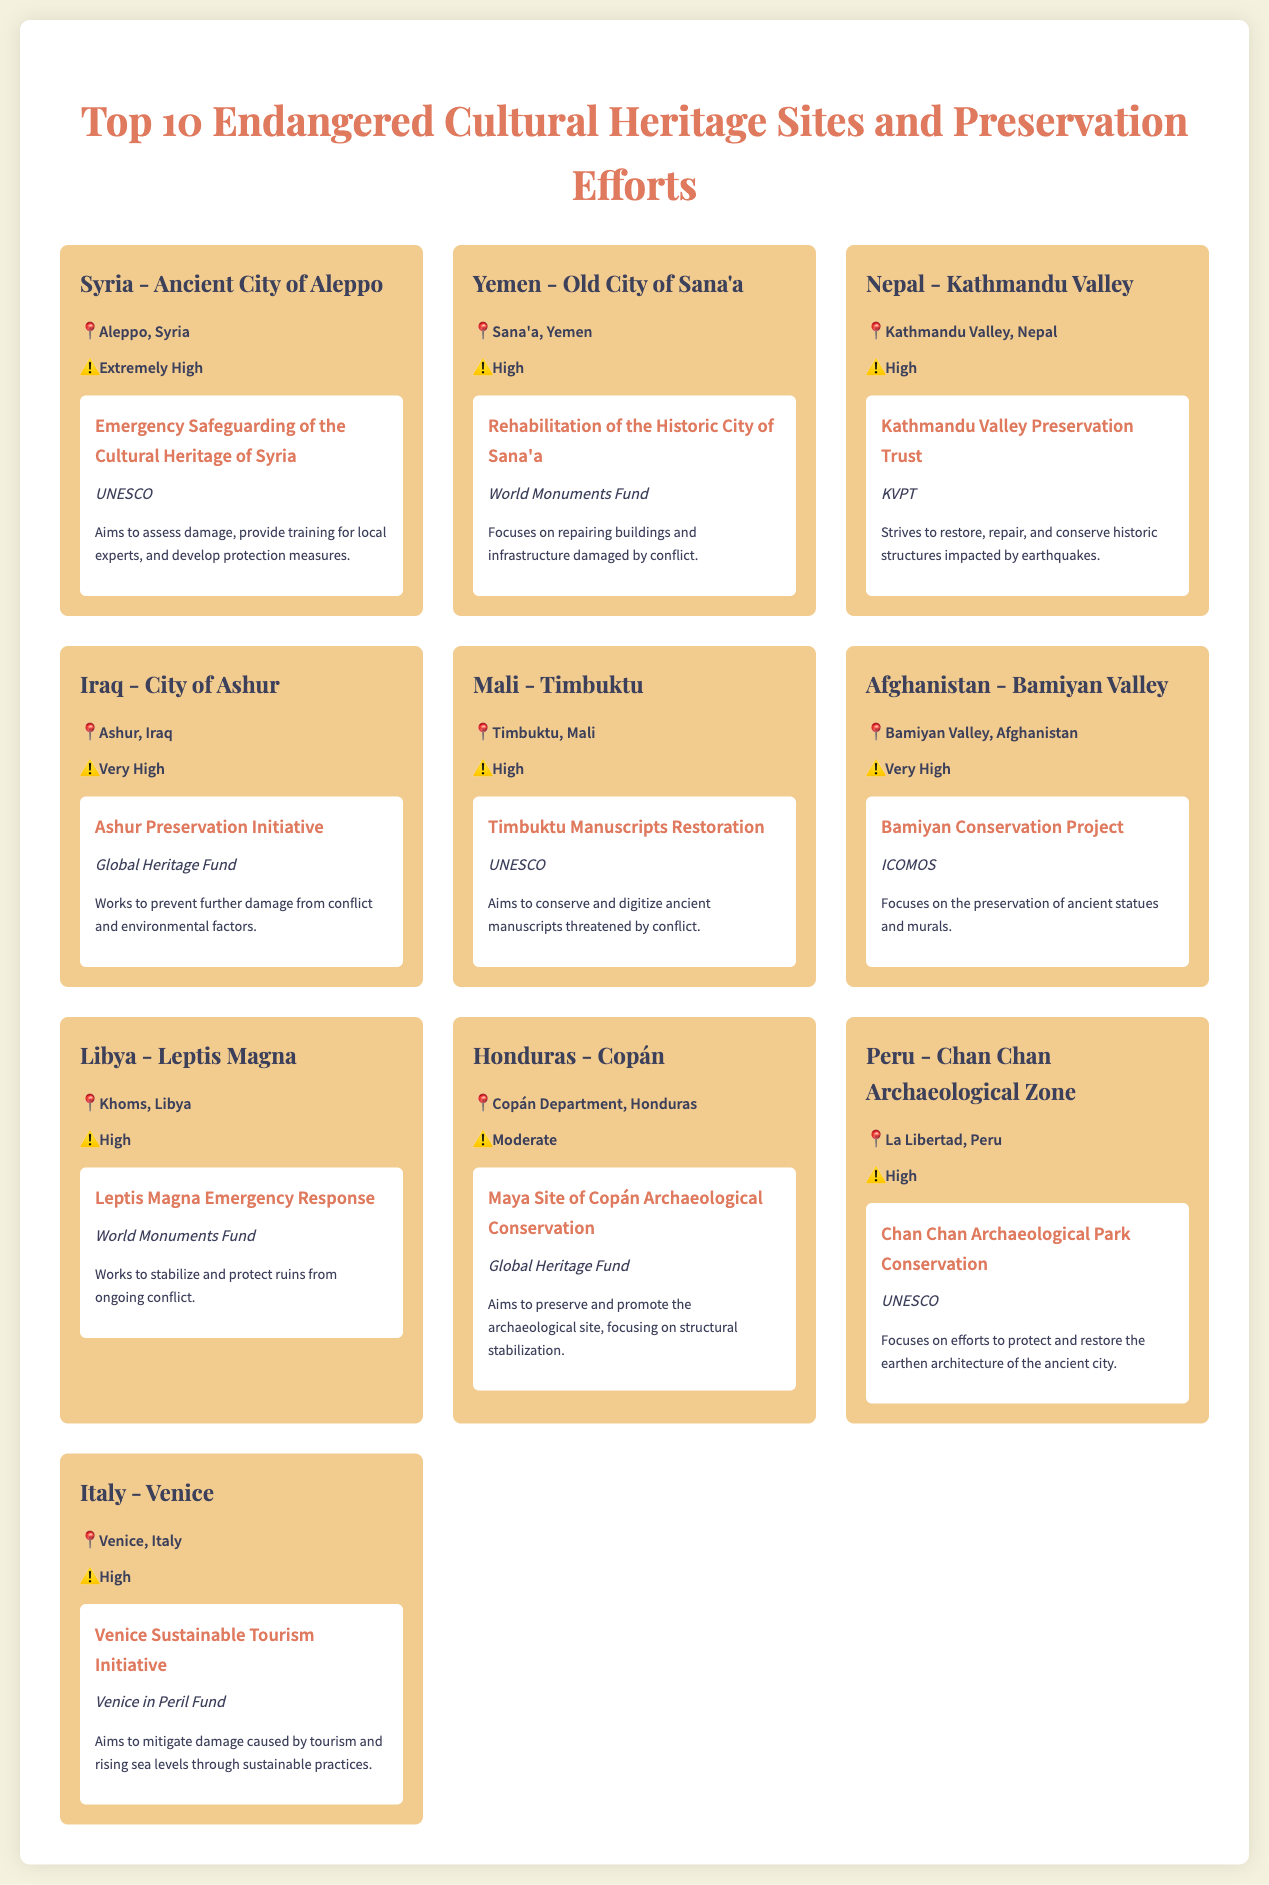What is the most endangered site listed? The site with the highest degree of endangerment is "Syria - Ancient City of Aleppo," which is classified as extremely high.
Answer: "Ancient City of Aleppo" Which organization is involved in the preservation of the Old City of Sana'a? The project for the Old City of Sana'a is organized by the World Monuments Fund.
Answer: World Monuments Fund How many sites are classified as having a very high endangerment level? Two sites are marked as very high in endangerment; they are "City of Ashur" and "Bamiyan Valley."
Answer: 2 What is the endangerment level of Chan Chan Archaeological Zone? The Chan Chan Archaeological Zone is classified as having a high level of endangerment.
Answer: High Which country is home to the Timbuktu site? Timbuktu is located in Mali.
Answer: Mali What preservation project focuses on the Venice sustainable tourism issue? The project aimed at addressing tourism damage and rising sea levels is the "Venice Sustainable Tourism Initiative."
Answer: Venice Sustainable Tourism Initiative Which site in Honduras has a moderate endangerment level? The archaeological site in Honduras with moderate endangerment is "Copán."
Answer: Copán Who is responsible for the Bamiyan Conservation Project? The Bamiyan Conservation Project is managed by ICOMOS.
Answer: ICOMOS 